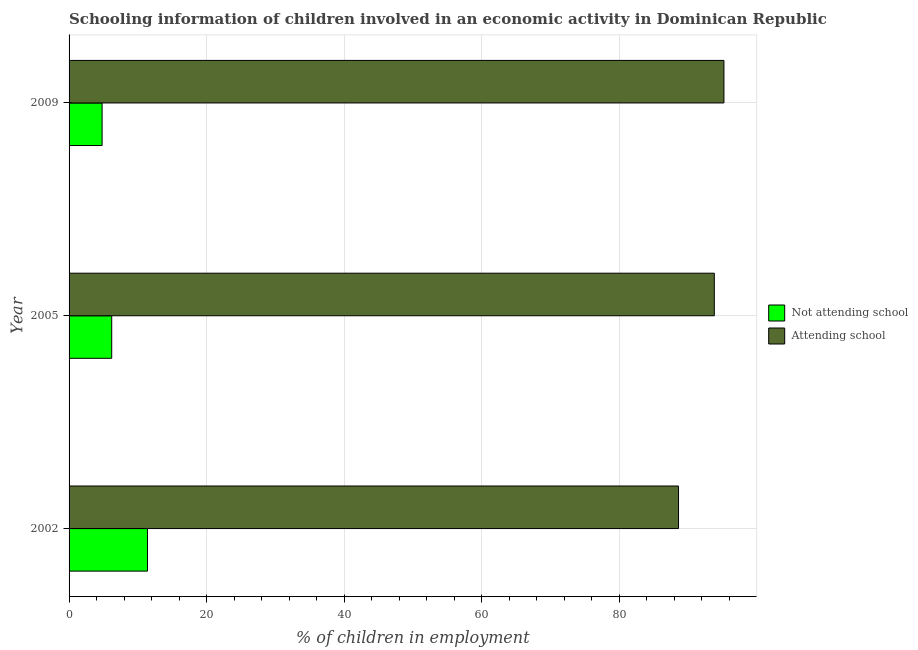How many groups of bars are there?
Provide a succinct answer. 3. Are the number of bars per tick equal to the number of legend labels?
Provide a succinct answer. Yes. How many bars are there on the 3rd tick from the bottom?
Your answer should be compact. 2. What is the label of the 3rd group of bars from the top?
Your response must be concise. 2002. In how many cases, is the number of bars for a given year not equal to the number of legend labels?
Keep it short and to the point. 0. What is the percentage of employed children who are attending school in 2005?
Offer a very short reply. 93.8. Across all years, what is the maximum percentage of employed children who are attending school?
Your answer should be very brief. 95.2. Across all years, what is the minimum percentage of employed children who are not attending school?
Provide a succinct answer. 4.8. In which year was the percentage of employed children who are not attending school minimum?
Provide a succinct answer. 2009. What is the total percentage of employed children who are attending school in the graph?
Your answer should be compact. 277.6. What is the difference between the percentage of employed children who are attending school in 2009 and the percentage of employed children who are not attending school in 2005?
Offer a very short reply. 89. What is the average percentage of employed children who are not attending school per year?
Offer a terse response. 7.47. In the year 2002, what is the difference between the percentage of employed children who are not attending school and percentage of employed children who are attending school?
Give a very brief answer. -77.2. In how many years, is the percentage of employed children who are not attending school greater than 72 %?
Your answer should be very brief. 0. What is the ratio of the percentage of employed children who are not attending school in 2002 to that in 2009?
Keep it short and to the point. 2.38. What is the difference between the highest and the lowest percentage of employed children who are attending school?
Offer a very short reply. 6.6. In how many years, is the percentage of employed children who are not attending school greater than the average percentage of employed children who are not attending school taken over all years?
Your answer should be very brief. 1. What does the 1st bar from the top in 2002 represents?
Make the answer very short. Attending school. What does the 2nd bar from the bottom in 2005 represents?
Offer a very short reply. Attending school. How many bars are there?
Your response must be concise. 6. Are all the bars in the graph horizontal?
Offer a very short reply. Yes. How many years are there in the graph?
Your answer should be very brief. 3. What is the difference between two consecutive major ticks on the X-axis?
Give a very brief answer. 20. Are the values on the major ticks of X-axis written in scientific E-notation?
Offer a terse response. No. Does the graph contain any zero values?
Keep it short and to the point. No. Does the graph contain grids?
Provide a succinct answer. Yes. Where does the legend appear in the graph?
Provide a succinct answer. Center right. How many legend labels are there?
Make the answer very short. 2. What is the title of the graph?
Keep it short and to the point. Schooling information of children involved in an economic activity in Dominican Republic. What is the label or title of the X-axis?
Make the answer very short. % of children in employment. What is the label or title of the Y-axis?
Your response must be concise. Year. What is the % of children in employment of Attending school in 2002?
Provide a short and direct response. 88.6. What is the % of children in employment of Attending school in 2005?
Your response must be concise. 93.8. What is the % of children in employment in Attending school in 2009?
Offer a terse response. 95.2. Across all years, what is the maximum % of children in employment in Attending school?
Make the answer very short. 95.2. Across all years, what is the minimum % of children in employment of Not attending school?
Ensure brevity in your answer.  4.8. Across all years, what is the minimum % of children in employment in Attending school?
Provide a succinct answer. 88.6. What is the total % of children in employment in Not attending school in the graph?
Offer a very short reply. 22.4. What is the total % of children in employment in Attending school in the graph?
Ensure brevity in your answer.  277.6. What is the difference between the % of children in employment of Not attending school in 2002 and the % of children in employment of Attending school in 2005?
Your answer should be very brief. -82.4. What is the difference between the % of children in employment of Not attending school in 2002 and the % of children in employment of Attending school in 2009?
Your answer should be compact. -83.8. What is the difference between the % of children in employment of Not attending school in 2005 and the % of children in employment of Attending school in 2009?
Offer a very short reply. -89. What is the average % of children in employment of Not attending school per year?
Your response must be concise. 7.47. What is the average % of children in employment in Attending school per year?
Your answer should be compact. 92.53. In the year 2002, what is the difference between the % of children in employment of Not attending school and % of children in employment of Attending school?
Ensure brevity in your answer.  -77.2. In the year 2005, what is the difference between the % of children in employment of Not attending school and % of children in employment of Attending school?
Your response must be concise. -87.6. In the year 2009, what is the difference between the % of children in employment of Not attending school and % of children in employment of Attending school?
Your response must be concise. -90.4. What is the ratio of the % of children in employment in Not attending school in 2002 to that in 2005?
Make the answer very short. 1.84. What is the ratio of the % of children in employment of Attending school in 2002 to that in 2005?
Provide a succinct answer. 0.94. What is the ratio of the % of children in employment of Not attending school in 2002 to that in 2009?
Provide a succinct answer. 2.38. What is the ratio of the % of children in employment in Attending school in 2002 to that in 2009?
Your answer should be compact. 0.93. What is the ratio of the % of children in employment in Not attending school in 2005 to that in 2009?
Offer a terse response. 1.29. What is the difference between the highest and the second highest % of children in employment in Attending school?
Your answer should be compact. 1.4. 